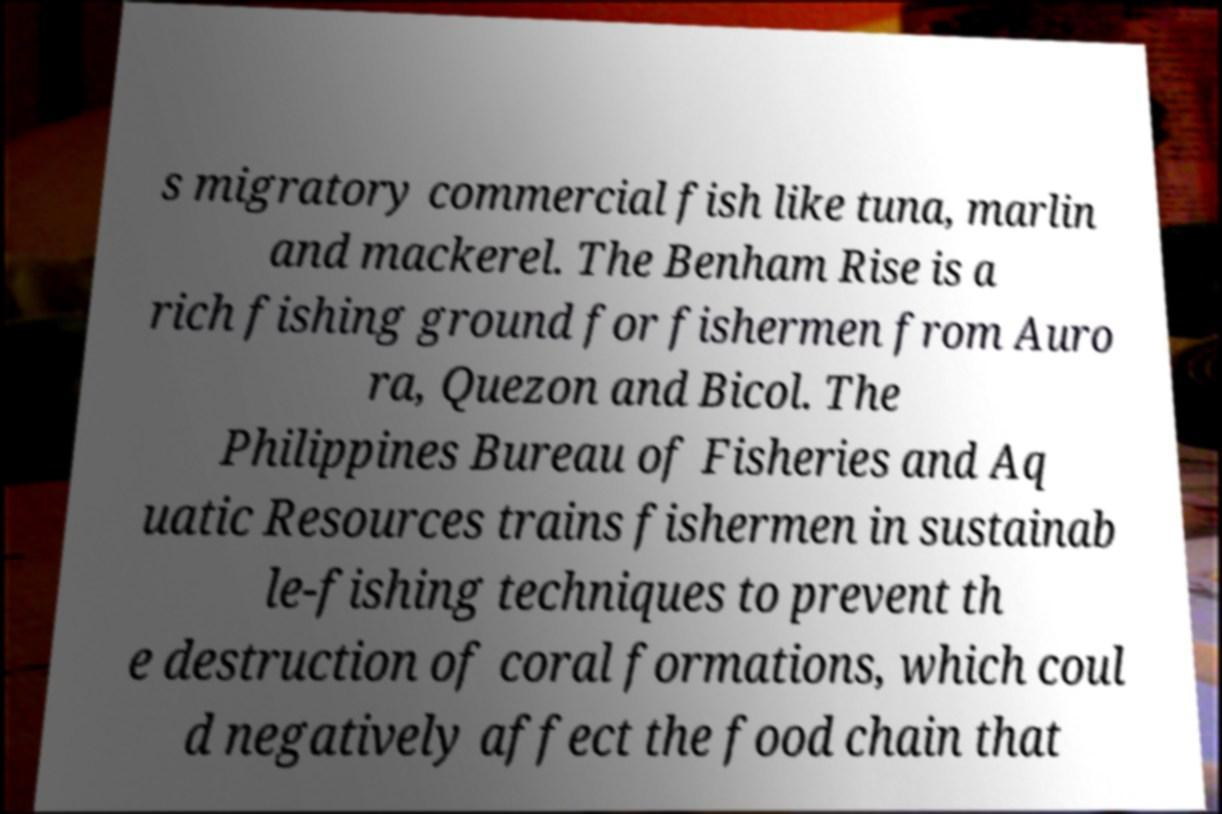Can you read and provide the text displayed in the image?This photo seems to have some interesting text. Can you extract and type it out for me? s migratory commercial fish like tuna, marlin and mackerel. The Benham Rise is a rich fishing ground for fishermen from Auro ra, Quezon and Bicol. The Philippines Bureau of Fisheries and Aq uatic Resources trains fishermen in sustainab le-fishing techniques to prevent th e destruction of coral formations, which coul d negatively affect the food chain that 